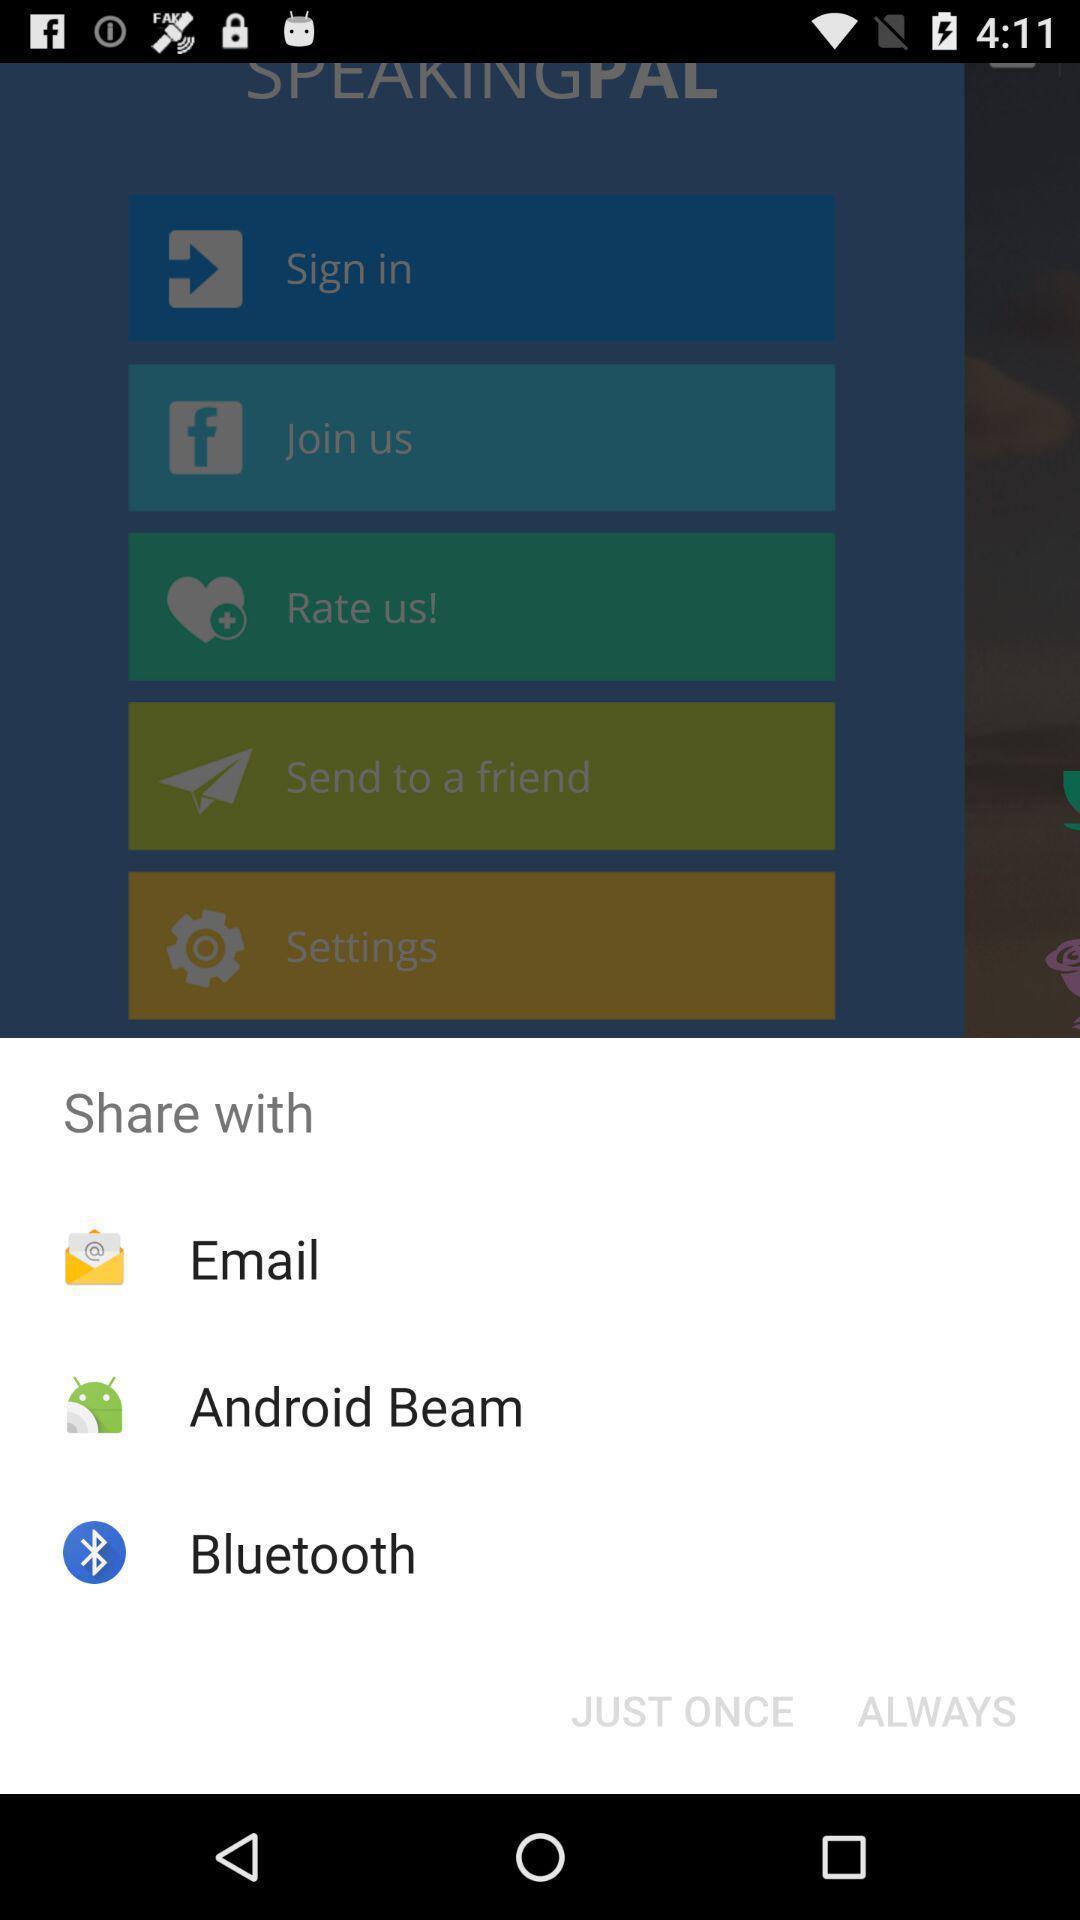What details can you identify in this image? Pop-up showing various share options. 